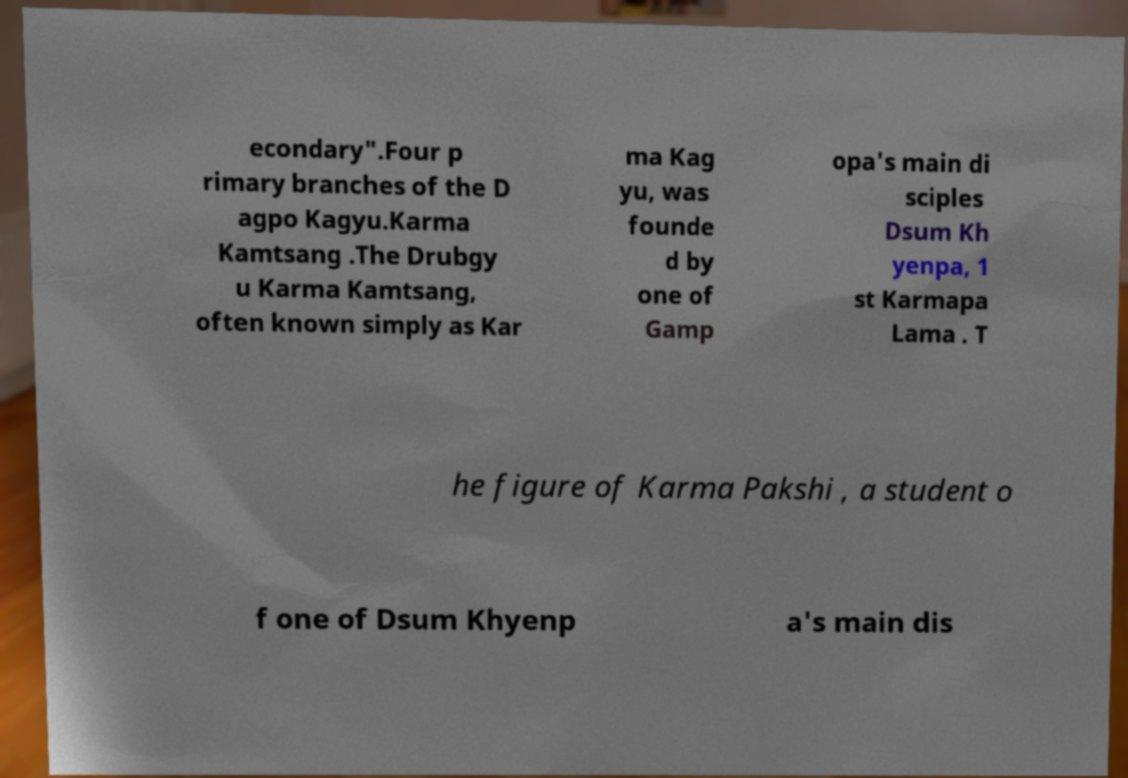I need the written content from this picture converted into text. Can you do that? econdary".Four p rimary branches of the D agpo Kagyu.Karma Kamtsang .The Drubgy u Karma Kamtsang, often known simply as Kar ma Kag yu, was founde d by one of Gamp opa's main di sciples Dsum Kh yenpa, 1 st Karmapa Lama . T he figure of Karma Pakshi , a student o f one of Dsum Khyenp a's main dis 